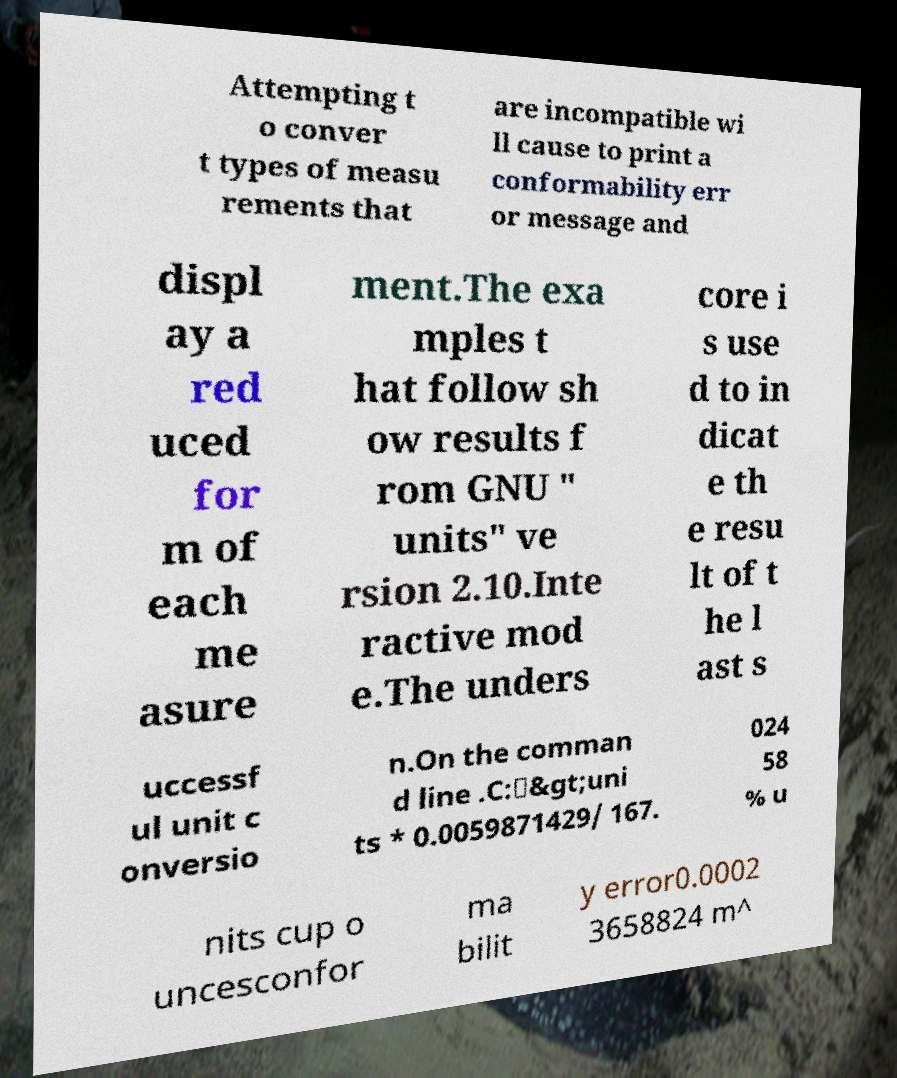Could you assist in decoding the text presented in this image and type it out clearly? Attempting t o conver t types of measu rements that are incompatible wi ll cause to print a conformability err or message and displ ay a red uced for m of each me asure ment.The exa mples t hat follow sh ow results f rom GNU " units" ve rsion 2.10.Inte ractive mod e.The unders core i s use d to in dicat e th e resu lt of t he l ast s uccessf ul unit c onversio n.On the comman d line .C:\&gt;uni ts * 0.0059871429/ 167. 024 58 % u nits cup o uncesconfor ma bilit y error0.0002 3658824 m^ 